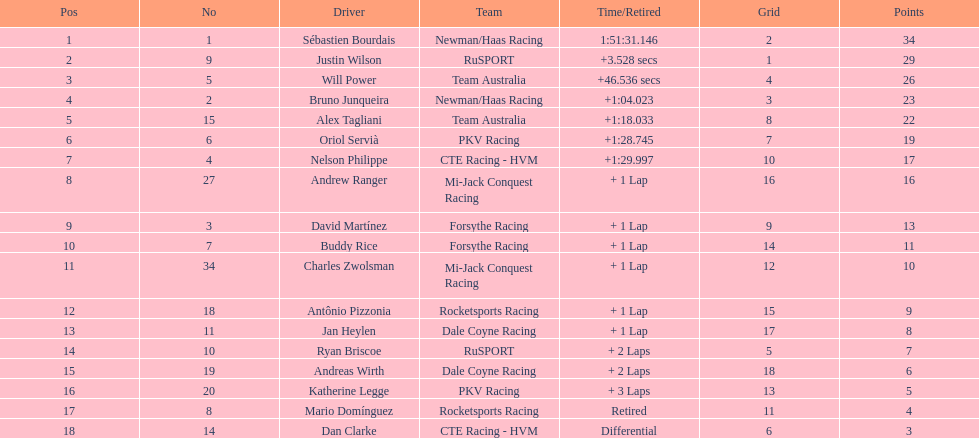Which country is represented by the most drivers? United Kingdom. 